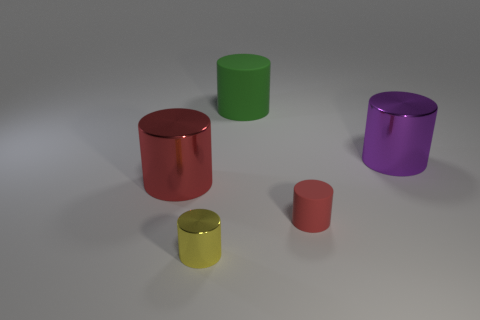Subtract 1 cylinders. How many cylinders are left? 4 Subtract all blue cylinders. Subtract all blue balls. How many cylinders are left? 5 Add 3 cylinders. How many objects exist? 8 Subtract 0 cyan cylinders. How many objects are left? 5 Subtract all tiny red things. Subtract all red metal things. How many objects are left? 3 Add 5 small yellow cylinders. How many small yellow cylinders are left? 6 Add 2 big green shiny spheres. How many big green shiny spheres exist? 2 